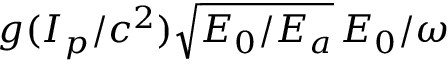<formula> <loc_0><loc_0><loc_500><loc_500>g ( I _ { p } / c ^ { 2 } ) \sqrt { E _ { 0 } / E _ { a } } \, E _ { 0 } / \omega</formula> 